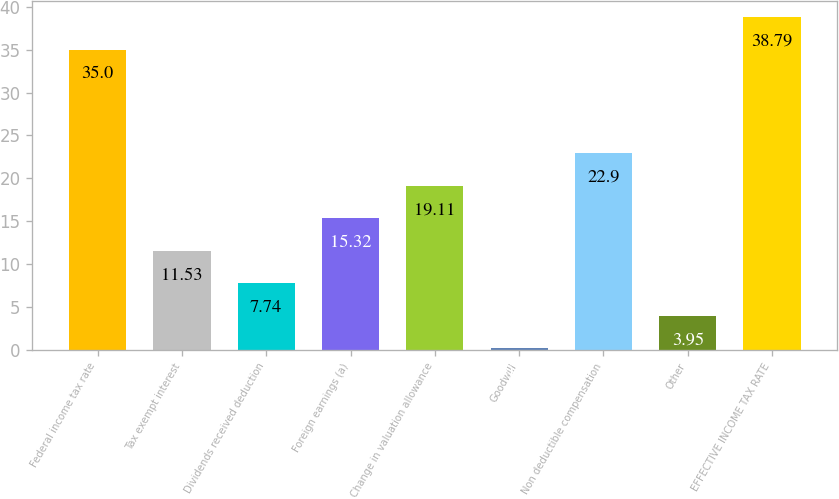Convert chart. <chart><loc_0><loc_0><loc_500><loc_500><bar_chart><fcel>Federal income tax rate<fcel>Tax exempt interest<fcel>Dividends received deduction<fcel>Foreign earnings (a)<fcel>Change in valuation allowance<fcel>Goodwill<fcel>Non deductible compensation<fcel>Other<fcel>EFFECTIVE INCOME TAX RATE<nl><fcel>35<fcel>11.53<fcel>7.74<fcel>15.32<fcel>19.11<fcel>0.16<fcel>22.9<fcel>3.95<fcel>38.79<nl></chart> 